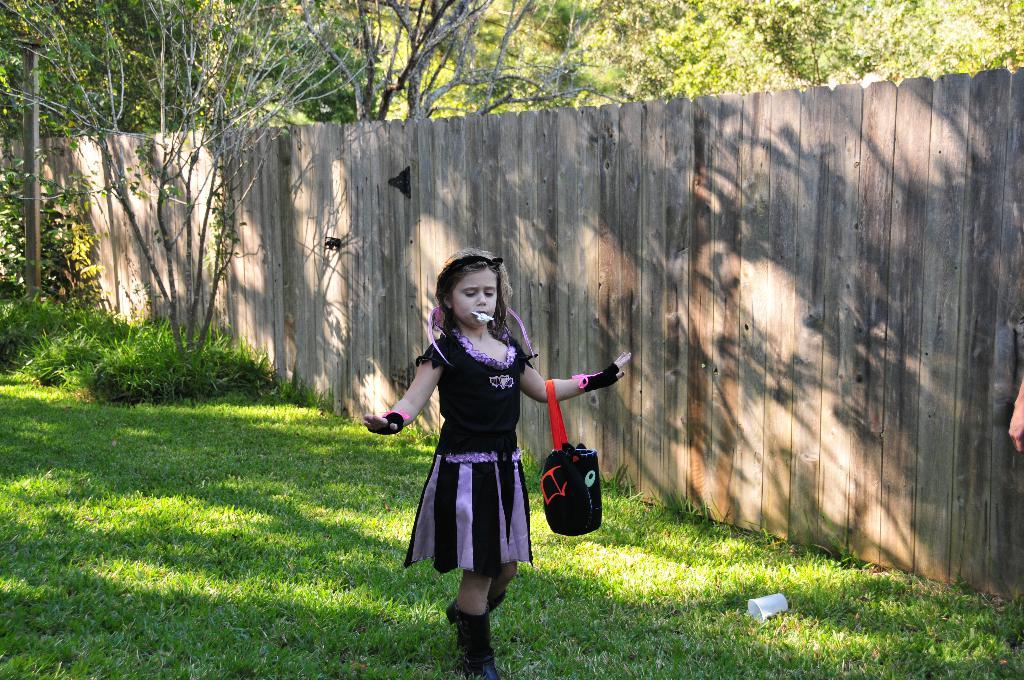Who is the main subject in the image? There is a girl standing in the image. What is the girl standing on? The girl is standing on the grass. What type of fencing can be seen in the image? There is wooden fencing in the image. What type of vegetation is visible in the image? There are plants and trees visible in the image. What type of star can be seen in the image? There is no star visible in the image; it is a photograph taken on Earth, featuring a girl, grass, wooden fencing, plants, and trees. 